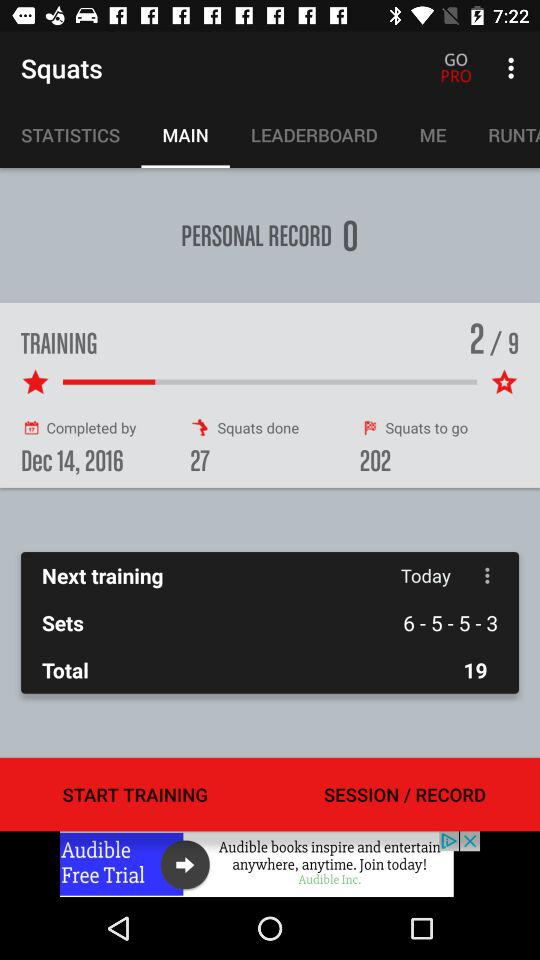By what date will the training be completed? The training will be completed by December 14, 2016. 